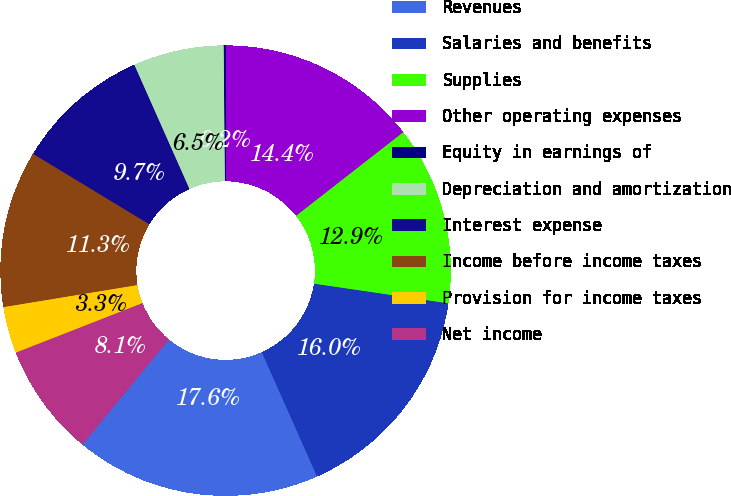Convert chart. <chart><loc_0><loc_0><loc_500><loc_500><pie_chart><fcel>Revenues<fcel>Salaries and benefits<fcel>Supplies<fcel>Other operating expenses<fcel>Equity in earnings of<fcel>Depreciation and amortization<fcel>Interest expense<fcel>Income before income taxes<fcel>Provision for income taxes<fcel>Net income<nl><fcel>17.62%<fcel>16.03%<fcel>12.86%<fcel>14.44%<fcel>0.16%<fcel>6.51%<fcel>9.68%<fcel>11.27%<fcel>3.34%<fcel>8.1%<nl></chart> 